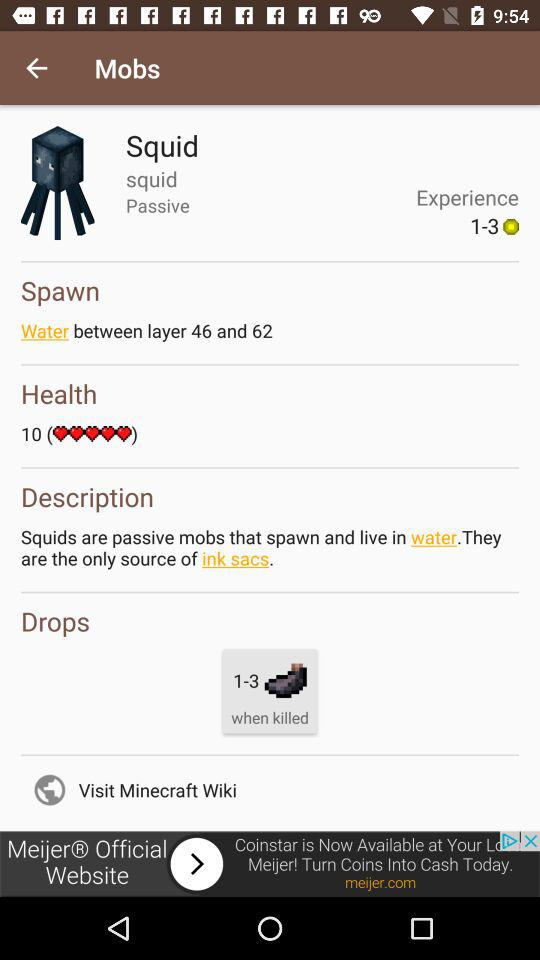How many hearts does a squid have?
Answer the question using a single word or phrase. 10 